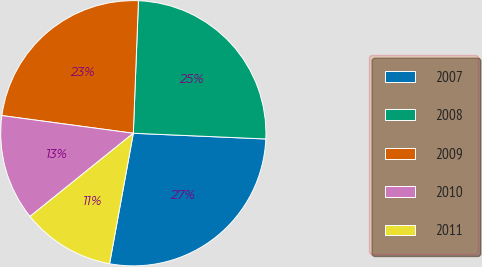Convert chart to OTSL. <chart><loc_0><loc_0><loc_500><loc_500><pie_chart><fcel>2007<fcel>2008<fcel>2009<fcel>2010<fcel>2011<nl><fcel>27.18%<fcel>25.07%<fcel>23.49%<fcel>12.92%<fcel>11.34%<nl></chart> 